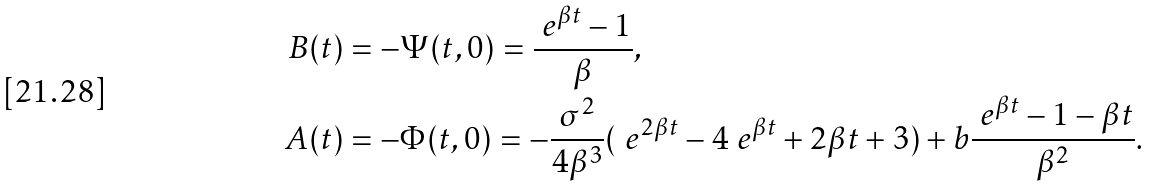<formula> <loc_0><loc_0><loc_500><loc_500>B ( t ) & = - \Psi ( t , 0 ) = \frac { \ e ^ { \beta t } - 1 } { \beta } , \\ A ( t ) & = - \Phi ( t , 0 ) = - \frac { \sigma ^ { 2 } } { 4 \beta ^ { 3 } } ( \ e ^ { 2 \beta t } - 4 \ e ^ { \beta t } + 2 \beta t + 3 ) + b \frac { \ e ^ { \beta t } - 1 - \beta t } { \beta ^ { 2 } } .</formula> 